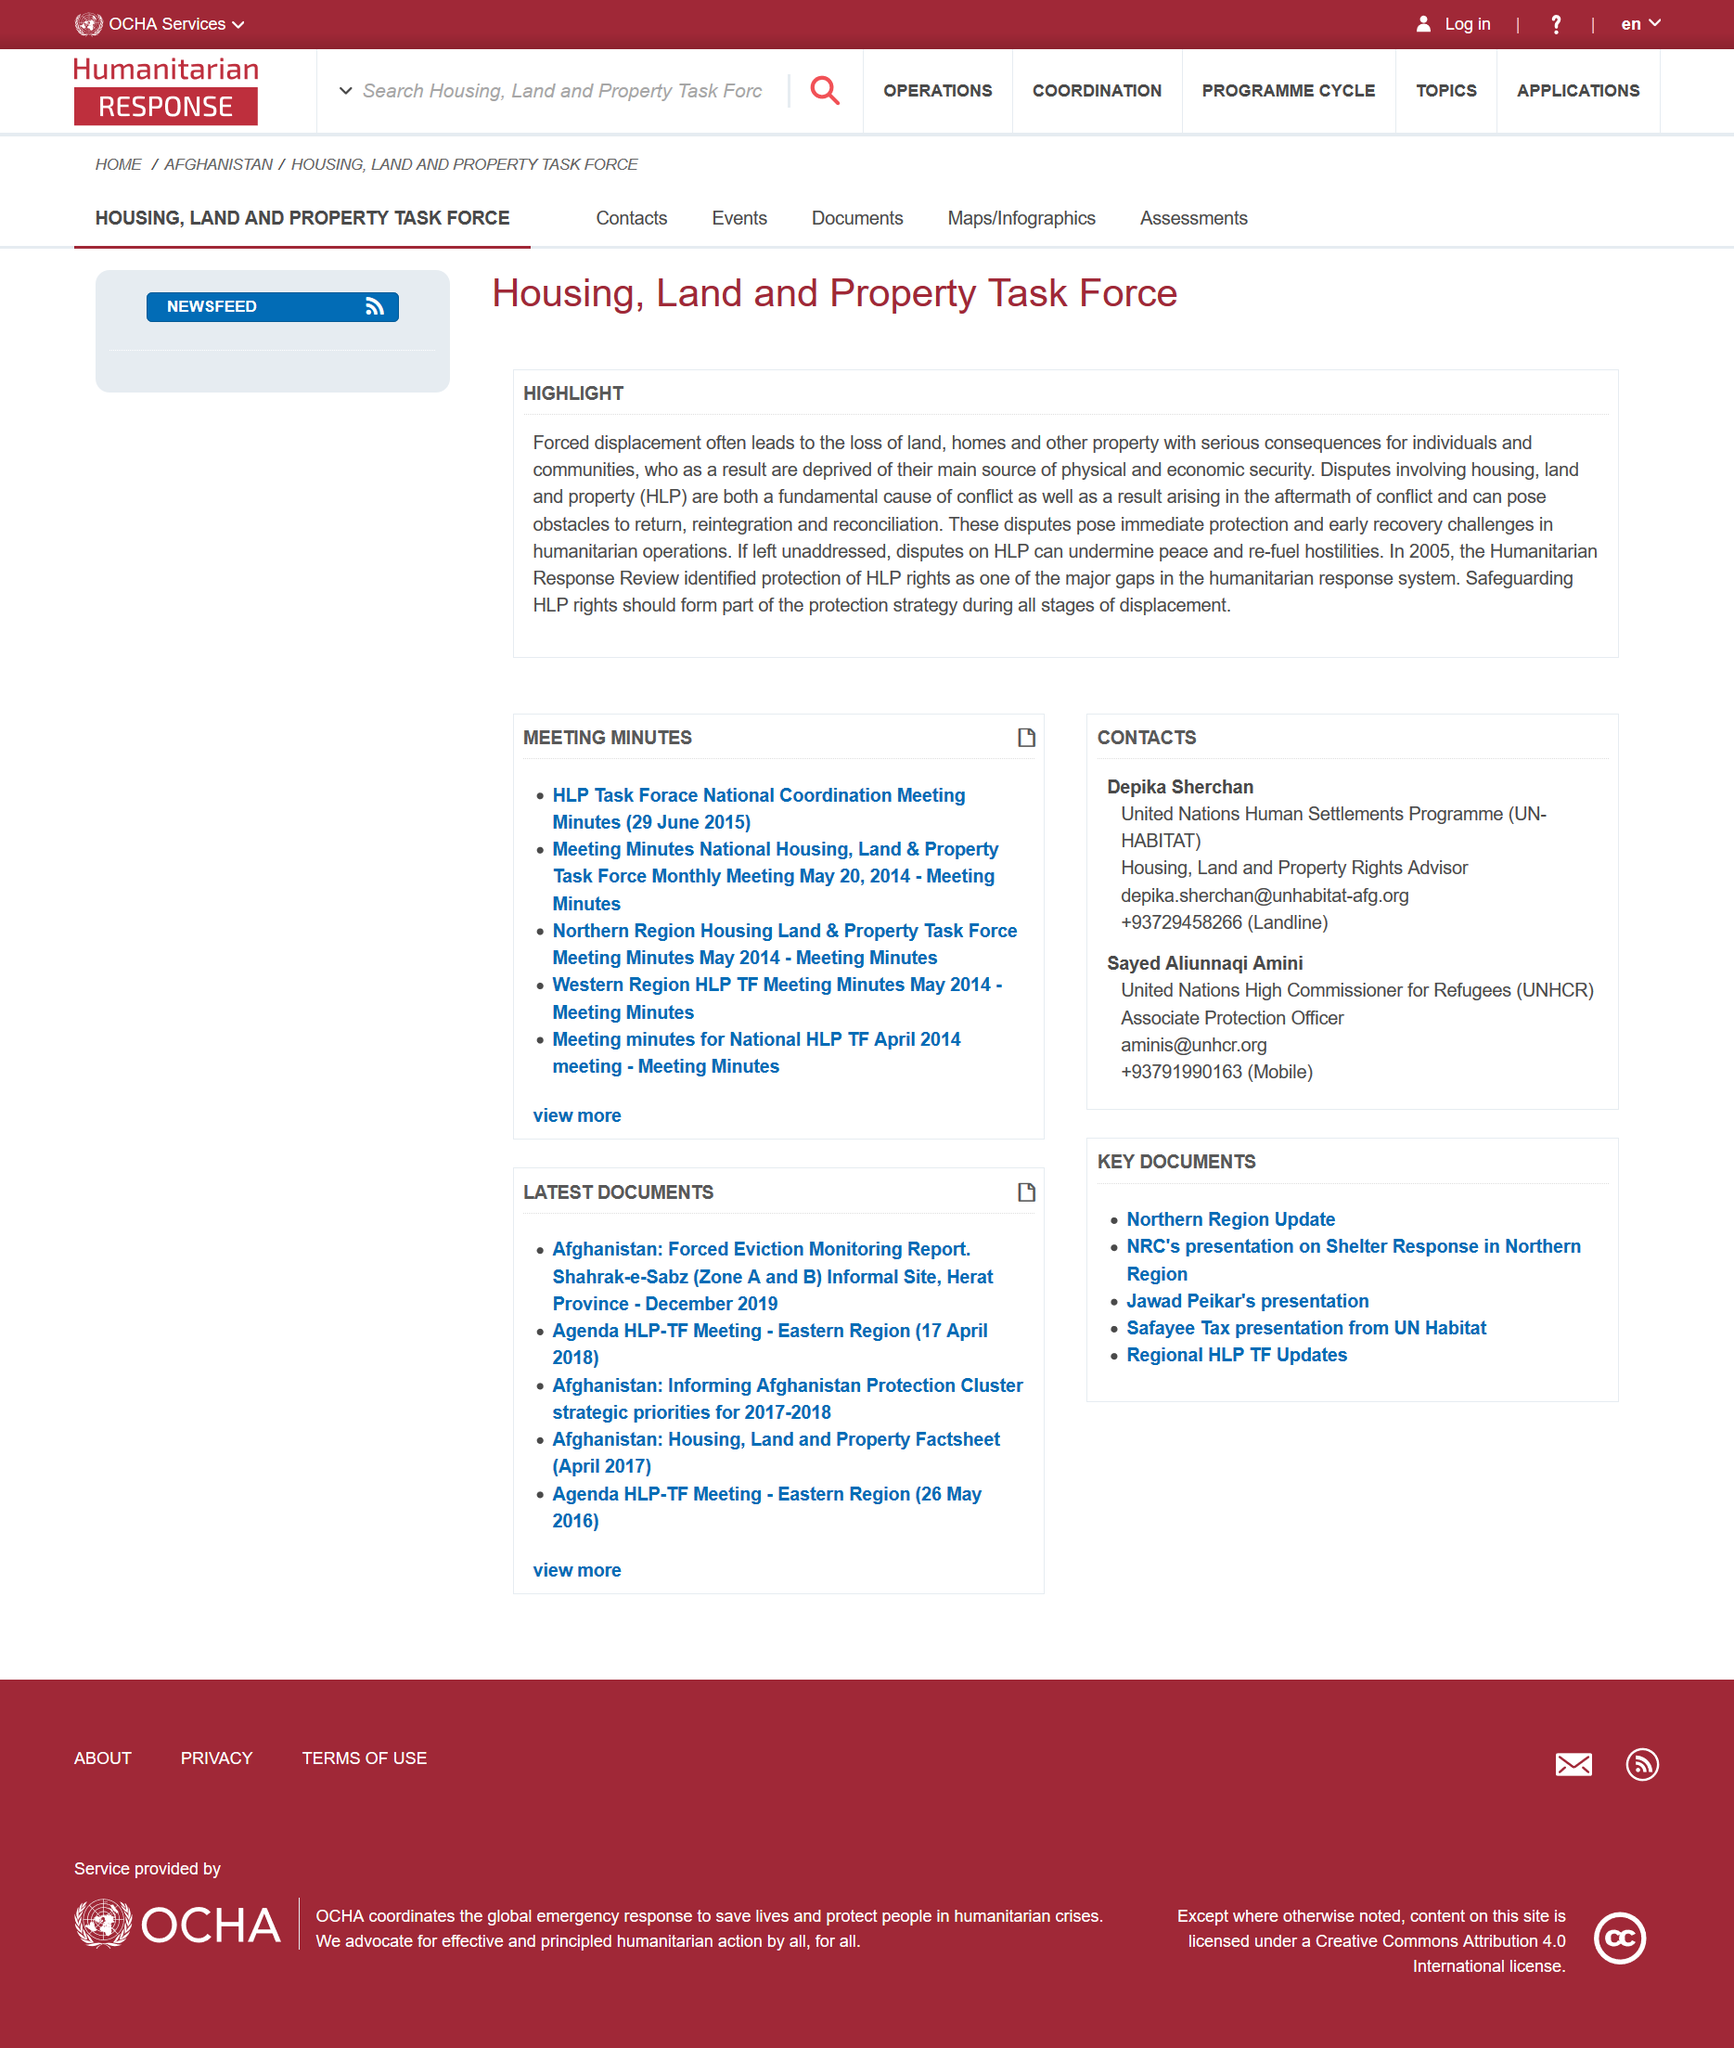Specify some key components in this picture. Housing, land, and property are collectively referred to as HLP. It is essential that safeguarding human rights from large-scale harm (HLP) be an integral component of all stages of development, as part of a comprehensive protection strategy. Yes, forced displacement often results in the loss of land, which is a significant highlight. 